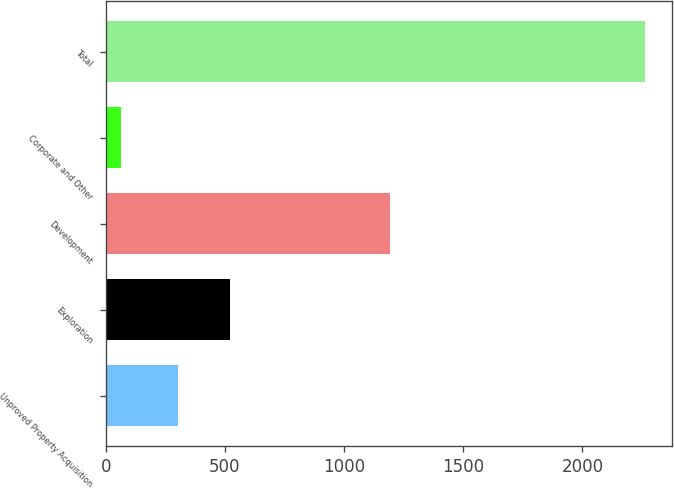Convert chart to OTSL. <chart><loc_0><loc_0><loc_500><loc_500><bar_chart><fcel>Unproved Property Acquisition<fcel>Exploration<fcel>Development<fcel>Corporate and Other<fcel>Total<nl><fcel>302<fcel>521.9<fcel>1193<fcel>65<fcel>2264<nl></chart> 